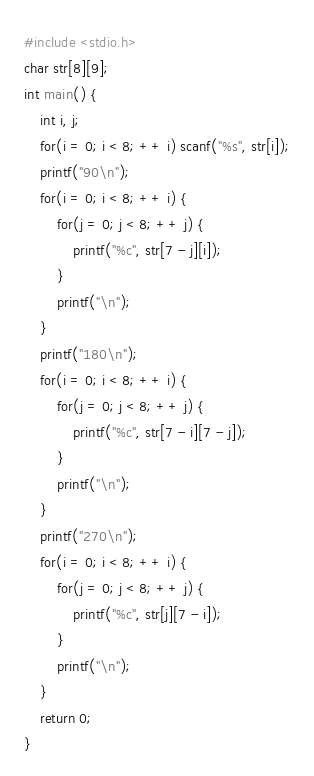Convert code to text. <code><loc_0><loc_0><loc_500><loc_500><_C_>#include <stdio.h>
char str[8][9];
int main() {
	int i, j;
	for(i = 0; i < 8; ++ i) scanf("%s", str[i]);
	printf("90\n");
	for(i = 0; i < 8; ++ i) {
		for(j = 0; j < 8; ++ j) {
			printf("%c", str[7 - j][i]);
		}
		printf("\n");
	}
	printf("180\n");
	for(i = 0; i < 8; ++ i) {
		for(j = 0; j < 8; ++ j) {
			printf("%c", str[7 - i][7 - j]);
		}
		printf("\n");
	}
	printf("270\n");
	for(i = 0; i < 8; ++ i) {
		for(j = 0; j < 8; ++ j) {
			printf("%c", str[j][7 - i]);
		}
		printf("\n");
	}
	return 0;
}</code> 